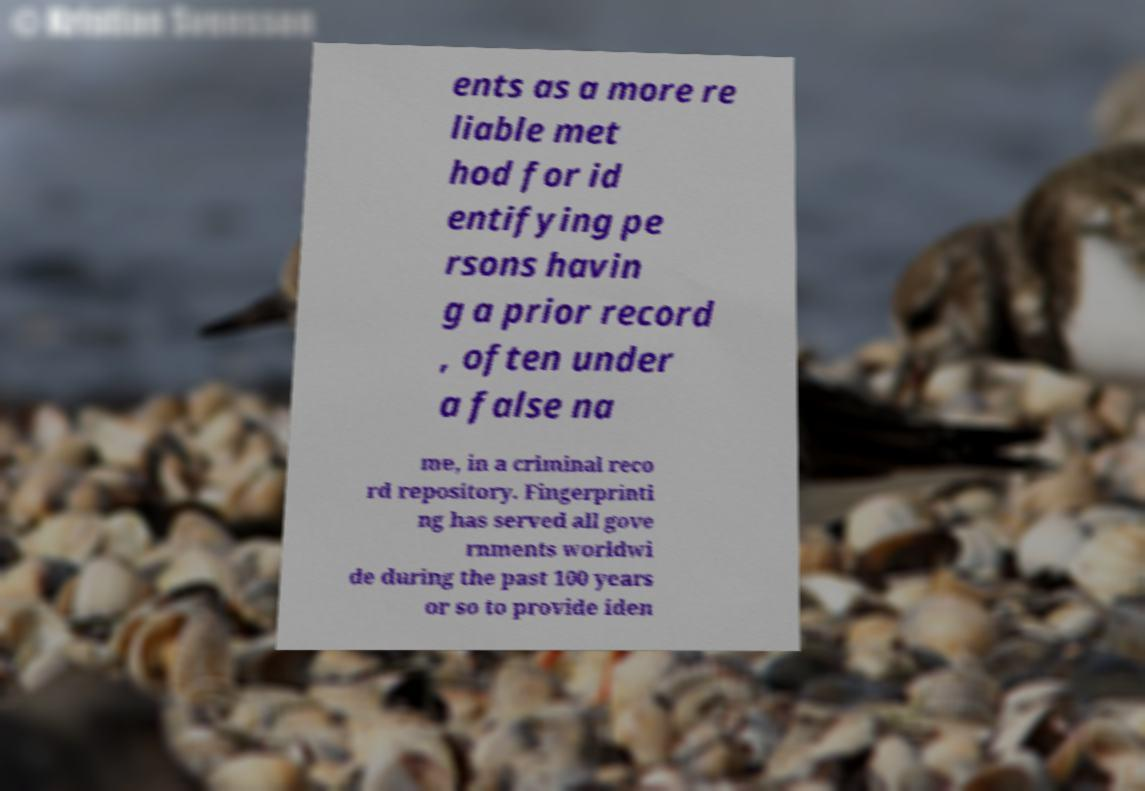Can you accurately transcribe the text from the provided image for me? ents as a more re liable met hod for id entifying pe rsons havin g a prior record , often under a false na me, in a criminal reco rd repository. Fingerprinti ng has served all gove rnments worldwi de during the past 100 years or so to provide iden 